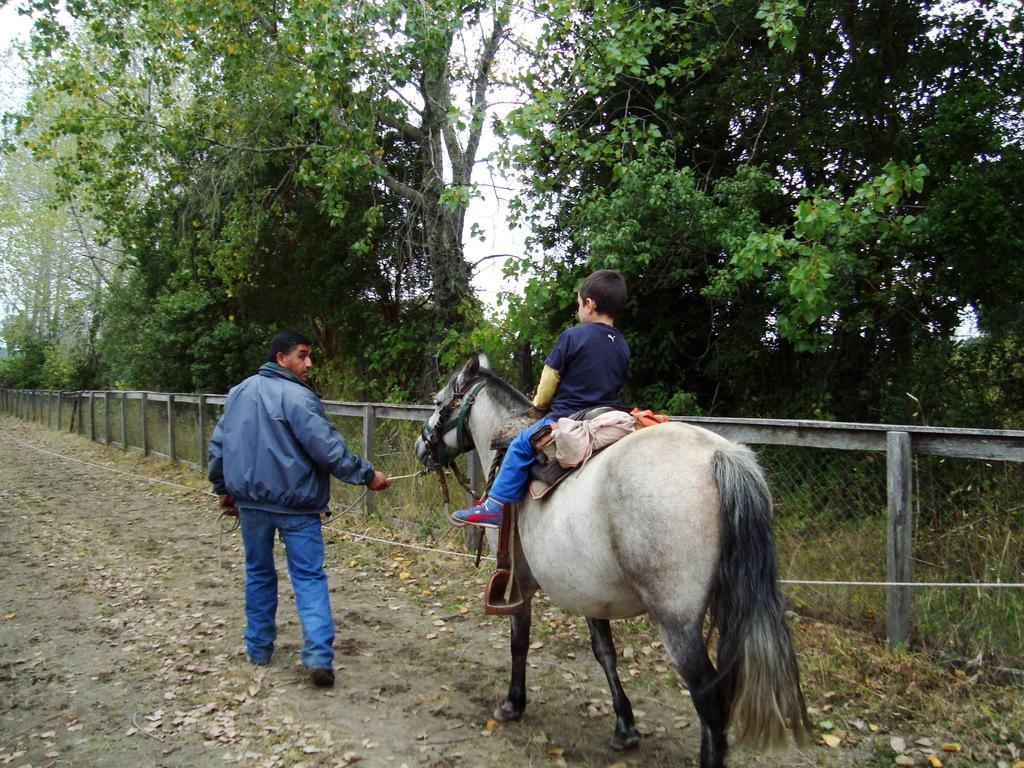What is the man in the image wearing? The man in the image is wearing a blue jacket. What is the man doing in the image? The man is standing in the image. Who else is present in the image besides the man? There is a boy in the image. What is the boy doing in the image? The boy is sitting on a horse in the image. What can be seen in the background of the image? There are trees and a fence in the image. What type of attraction can be seen in the image? There is no attraction present in the image; it features a man, a boy on a horse, trees, and a fence. What sound does the alarm make in the image? There is no alarm present in the image. 